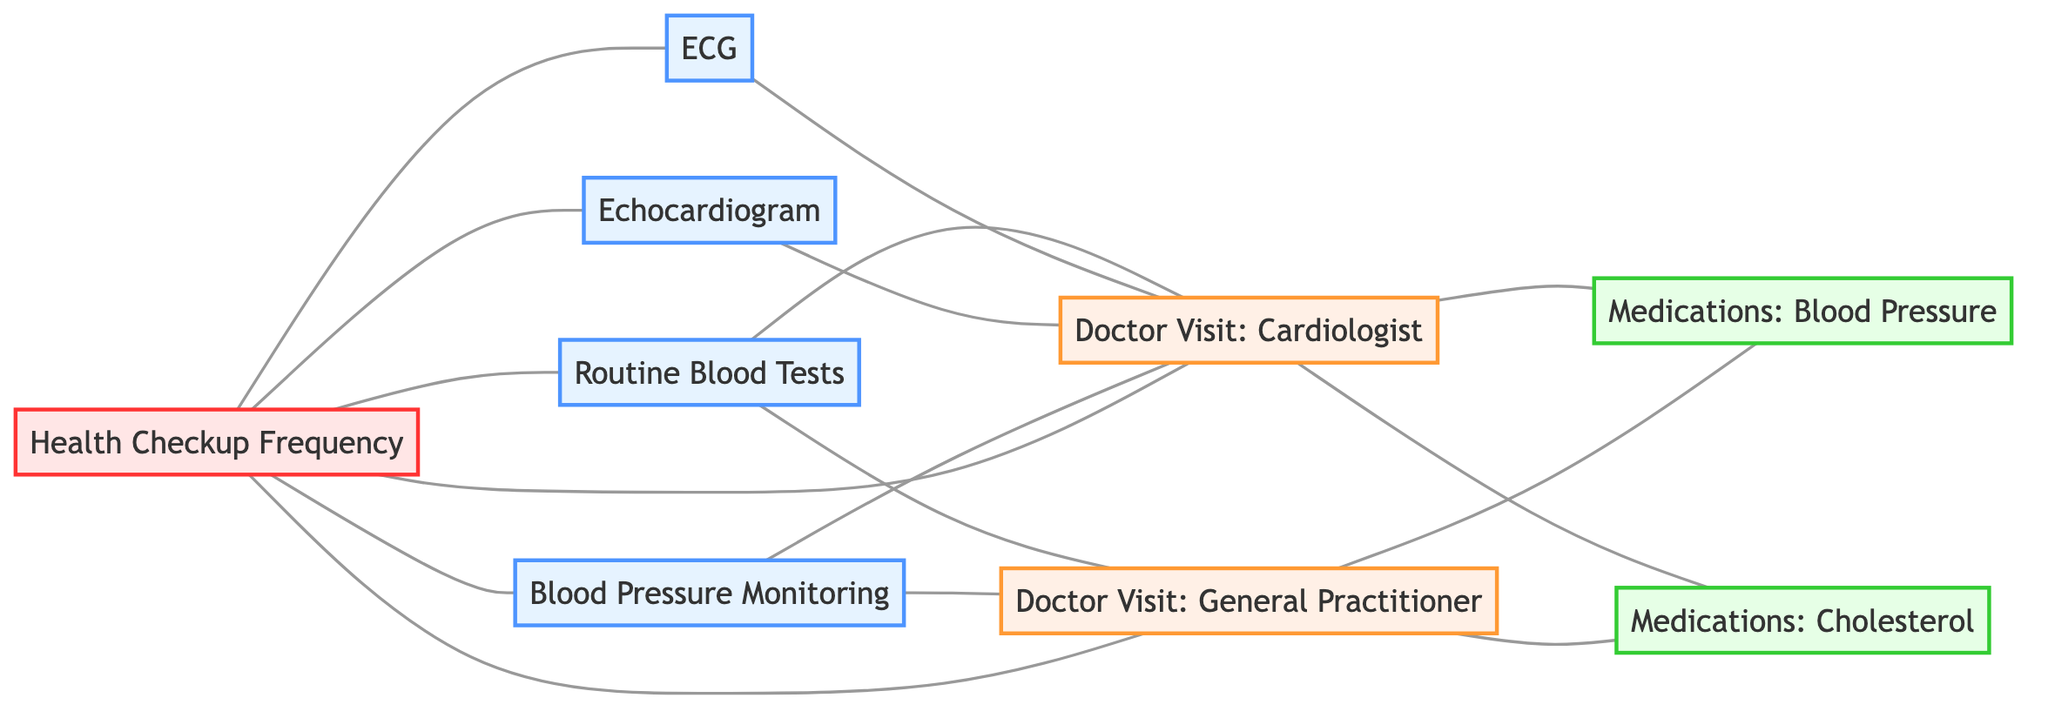What types of tests are associated with the Cardiologist? By examining the edges connected to the "Doctor Visit: Cardiologist" node, you can see that both "Routine Blood Tests", "ECG", and "Echocardiogram" are linked to it as tests.
Answer: Routine Blood Tests, ECG, Echocardiogram How many types of medications are linked to the General Practitioner? Looking at the node "Doctor Visit: General Practitioner" and counting the edges that connect it to medication nodes, I find there are two linked medications: "Medications: Blood Pressure" and "Medications: Cholesterol".
Answer: 2 Which test is connected to both Doctor Visits? By reviewing the connections, "Blood Pressure Monitoring" shows edges connecting to both "Doctor Visit: Cardiologist" and "Doctor Visit: General Practitioner", indicating its relationship with both.
Answer: Blood Pressure Monitoring What frequency of health checkups is indicated for routine tests? The "Health Checkup Frequency" node connects to several test nodes: "Routine Blood Tests", "ECG", "Blood Pressure Monitoring", and "Echocardiogram", highlighting the frequency of those tests needed during health checkups.
Answer: Routine Blood Tests, ECG, Blood Pressure Monitoring, Echocardiogram How many total nodes are in this graph? By counting all nodes listed in the data, I find there are eight different nodes present in the graph: all the tests, doctor visits, medications, and frequencies.
Answer: 8 Do Blood Pressure medications connect to both types of Doctor Visits? The node "Medications: Blood Pressure" connects through edges to both "Doctor Visit: Cardiologist" and "Doctor Visit: General Practitioner", confirming it is associated with both types of visits.
Answer: Yes 